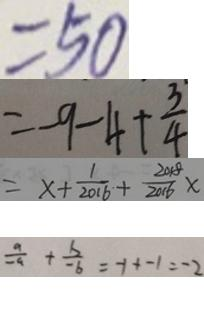Convert formula to latex. <formula><loc_0><loc_0><loc_500><loc_500>= 5 0 
 = - 9 - 4 + \frac { 3 } { 4 } 
 = x + \frac { 1 } { 2 0 1 6 } + \frac { 2 0 1 8 } { 2 0 1 6 } x 
 \frac { a } { - a } + \frac { b } { - b } = - 1 + - 1 = - 2</formula> 